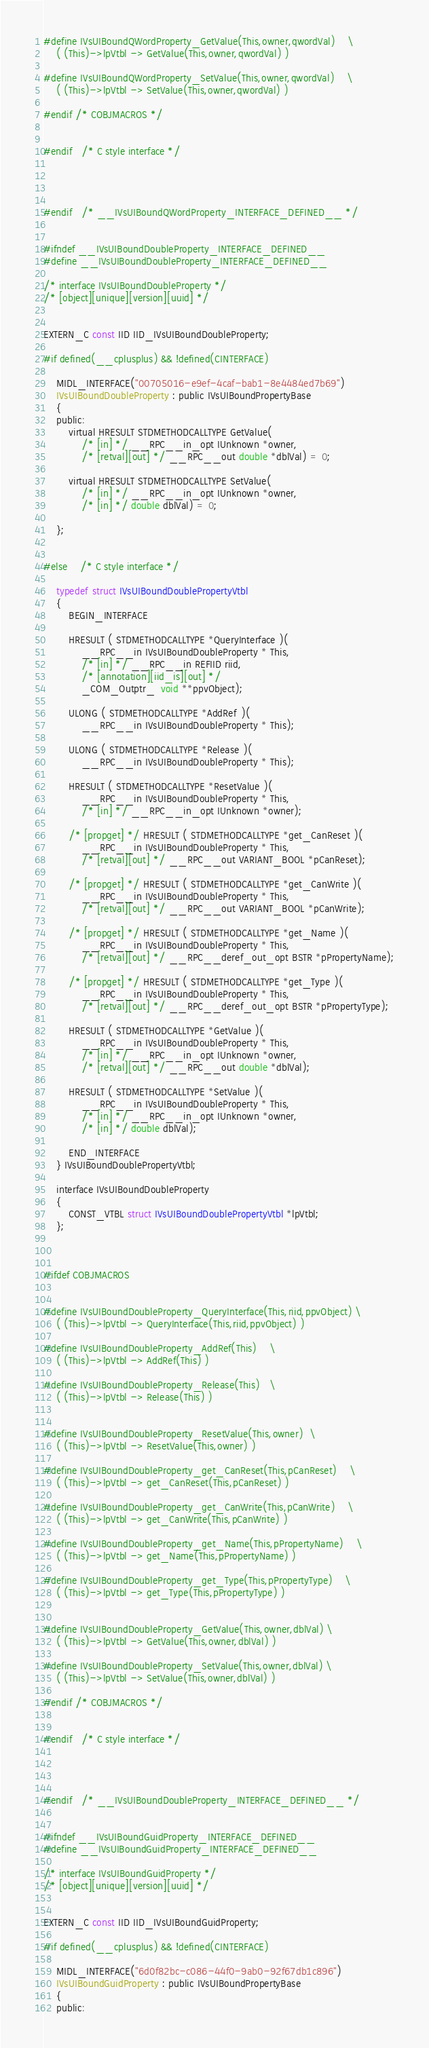<code> <loc_0><loc_0><loc_500><loc_500><_C_>#define IVsUIBoundQWordProperty_GetValue(This,owner,qwordVal)	\
    ( (This)->lpVtbl -> GetValue(This,owner,qwordVal) ) 

#define IVsUIBoundQWordProperty_SetValue(This,owner,qwordVal)	\
    ( (This)->lpVtbl -> SetValue(This,owner,qwordVal) ) 

#endif /* COBJMACROS */


#endif 	/* C style interface */




#endif 	/* __IVsUIBoundQWordProperty_INTERFACE_DEFINED__ */


#ifndef __IVsUIBoundDoubleProperty_INTERFACE_DEFINED__
#define __IVsUIBoundDoubleProperty_INTERFACE_DEFINED__

/* interface IVsUIBoundDoubleProperty */
/* [object][unique][version][uuid] */ 


EXTERN_C const IID IID_IVsUIBoundDoubleProperty;

#if defined(__cplusplus) && !defined(CINTERFACE)
    
    MIDL_INTERFACE("00705016-e9ef-4caf-bab1-8e4484ed7b69")
    IVsUIBoundDoubleProperty : public IVsUIBoundPropertyBase
    {
    public:
        virtual HRESULT STDMETHODCALLTYPE GetValue( 
            /* [in] */ __RPC__in_opt IUnknown *owner,
            /* [retval][out] */ __RPC__out double *dblVal) = 0;
        
        virtual HRESULT STDMETHODCALLTYPE SetValue( 
            /* [in] */ __RPC__in_opt IUnknown *owner,
            /* [in] */ double dblVal) = 0;
        
    };
    
    
#else 	/* C style interface */

    typedef struct IVsUIBoundDoublePropertyVtbl
    {
        BEGIN_INTERFACE
        
        HRESULT ( STDMETHODCALLTYPE *QueryInterface )( 
            __RPC__in IVsUIBoundDoubleProperty * This,
            /* [in] */ __RPC__in REFIID riid,
            /* [annotation][iid_is][out] */ 
            _COM_Outptr_  void **ppvObject);
        
        ULONG ( STDMETHODCALLTYPE *AddRef )( 
            __RPC__in IVsUIBoundDoubleProperty * This);
        
        ULONG ( STDMETHODCALLTYPE *Release )( 
            __RPC__in IVsUIBoundDoubleProperty * This);
        
        HRESULT ( STDMETHODCALLTYPE *ResetValue )( 
            __RPC__in IVsUIBoundDoubleProperty * This,
            /* [in] */ __RPC__in_opt IUnknown *owner);
        
        /* [propget] */ HRESULT ( STDMETHODCALLTYPE *get_CanReset )( 
            __RPC__in IVsUIBoundDoubleProperty * This,
            /* [retval][out] */ __RPC__out VARIANT_BOOL *pCanReset);
        
        /* [propget] */ HRESULT ( STDMETHODCALLTYPE *get_CanWrite )( 
            __RPC__in IVsUIBoundDoubleProperty * This,
            /* [retval][out] */ __RPC__out VARIANT_BOOL *pCanWrite);
        
        /* [propget] */ HRESULT ( STDMETHODCALLTYPE *get_Name )( 
            __RPC__in IVsUIBoundDoubleProperty * This,
            /* [retval][out] */ __RPC__deref_out_opt BSTR *pPropertyName);
        
        /* [propget] */ HRESULT ( STDMETHODCALLTYPE *get_Type )( 
            __RPC__in IVsUIBoundDoubleProperty * This,
            /* [retval][out] */ __RPC__deref_out_opt BSTR *pPropertyType);
        
        HRESULT ( STDMETHODCALLTYPE *GetValue )( 
            __RPC__in IVsUIBoundDoubleProperty * This,
            /* [in] */ __RPC__in_opt IUnknown *owner,
            /* [retval][out] */ __RPC__out double *dblVal);
        
        HRESULT ( STDMETHODCALLTYPE *SetValue )( 
            __RPC__in IVsUIBoundDoubleProperty * This,
            /* [in] */ __RPC__in_opt IUnknown *owner,
            /* [in] */ double dblVal);
        
        END_INTERFACE
    } IVsUIBoundDoublePropertyVtbl;

    interface IVsUIBoundDoubleProperty
    {
        CONST_VTBL struct IVsUIBoundDoublePropertyVtbl *lpVtbl;
    };

    

#ifdef COBJMACROS


#define IVsUIBoundDoubleProperty_QueryInterface(This,riid,ppvObject)	\
    ( (This)->lpVtbl -> QueryInterface(This,riid,ppvObject) ) 

#define IVsUIBoundDoubleProperty_AddRef(This)	\
    ( (This)->lpVtbl -> AddRef(This) ) 

#define IVsUIBoundDoubleProperty_Release(This)	\
    ( (This)->lpVtbl -> Release(This) ) 


#define IVsUIBoundDoubleProperty_ResetValue(This,owner)	\
    ( (This)->lpVtbl -> ResetValue(This,owner) ) 

#define IVsUIBoundDoubleProperty_get_CanReset(This,pCanReset)	\
    ( (This)->lpVtbl -> get_CanReset(This,pCanReset) ) 

#define IVsUIBoundDoubleProperty_get_CanWrite(This,pCanWrite)	\
    ( (This)->lpVtbl -> get_CanWrite(This,pCanWrite) ) 

#define IVsUIBoundDoubleProperty_get_Name(This,pPropertyName)	\
    ( (This)->lpVtbl -> get_Name(This,pPropertyName) ) 

#define IVsUIBoundDoubleProperty_get_Type(This,pPropertyType)	\
    ( (This)->lpVtbl -> get_Type(This,pPropertyType) ) 


#define IVsUIBoundDoubleProperty_GetValue(This,owner,dblVal)	\
    ( (This)->lpVtbl -> GetValue(This,owner,dblVal) ) 

#define IVsUIBoundDoubleProperty_SetValue(This,owner,dblVal)	\
    ( (This)->lpVtbl -> SetValue(This,owner,dblVal) ) 

#endif /* COBJMACROS */


#endif 	/* C style interface */




#endif 	/* __IVsUIBoundDoubleProperty_INTERFACE_DEFINED__ */


#ifndef __IVsUIBoundGuidProperty_INTERFACE_DEFINED__
#define __IVsUIBoundGuidProperty_INTERFACE_DEFINED__

/* interface IVsUIBoundGuidProperty */
/* [object][unique][version][uuid] */ 


EXTERN_C const IID IID_IVsUIBoundGuidProperty;

#if defined(__cplusplus) && !defined(CINTERFACE)
    
    MIDL_INTERFACE("6d0f82bc-c086-44f0-9ab0-92f67db1c896")
    IVsUIBoundGuidProperty : public IVsUIBoundPropertyBase
    {
    public:</code> 